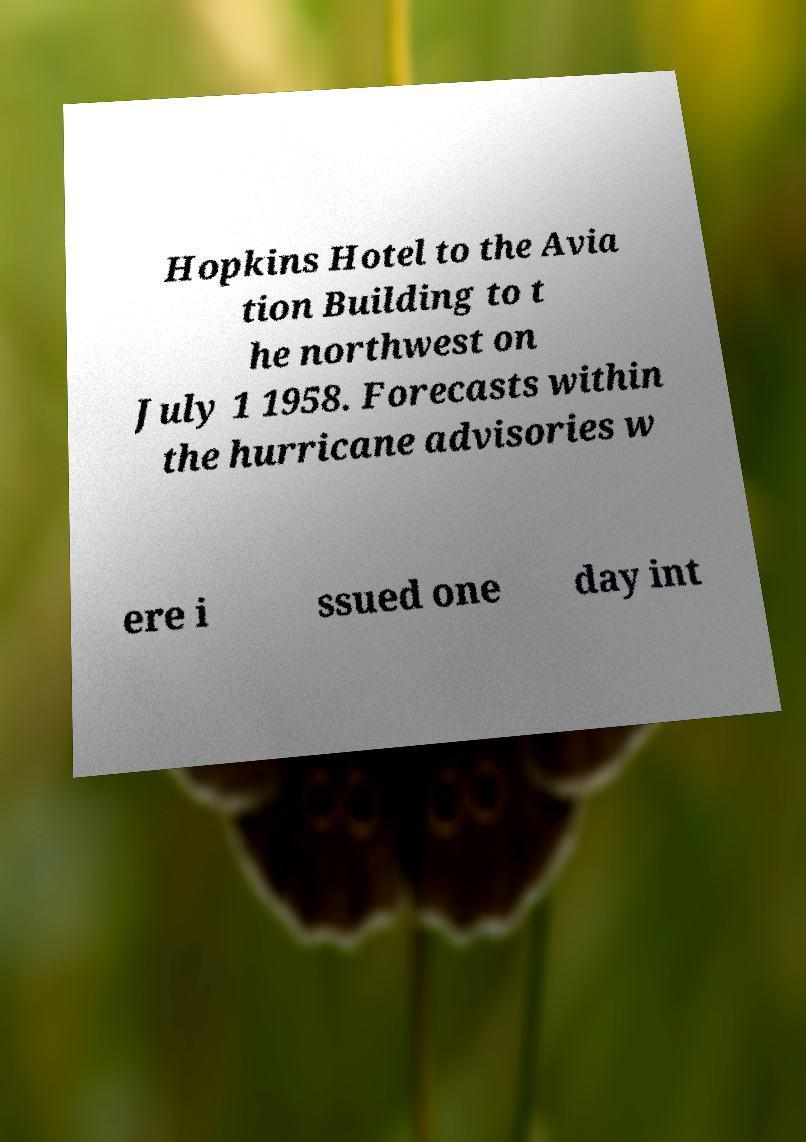Can you read and provide the text displayed in the image?This photo seems to have some interesting text. Can you extract and type it out for me? Hopkins Hotel to the Avia tion Building to t he northwest on July 1 1958. Forecasts within the hurricane advisories w ere i ssued one day int 